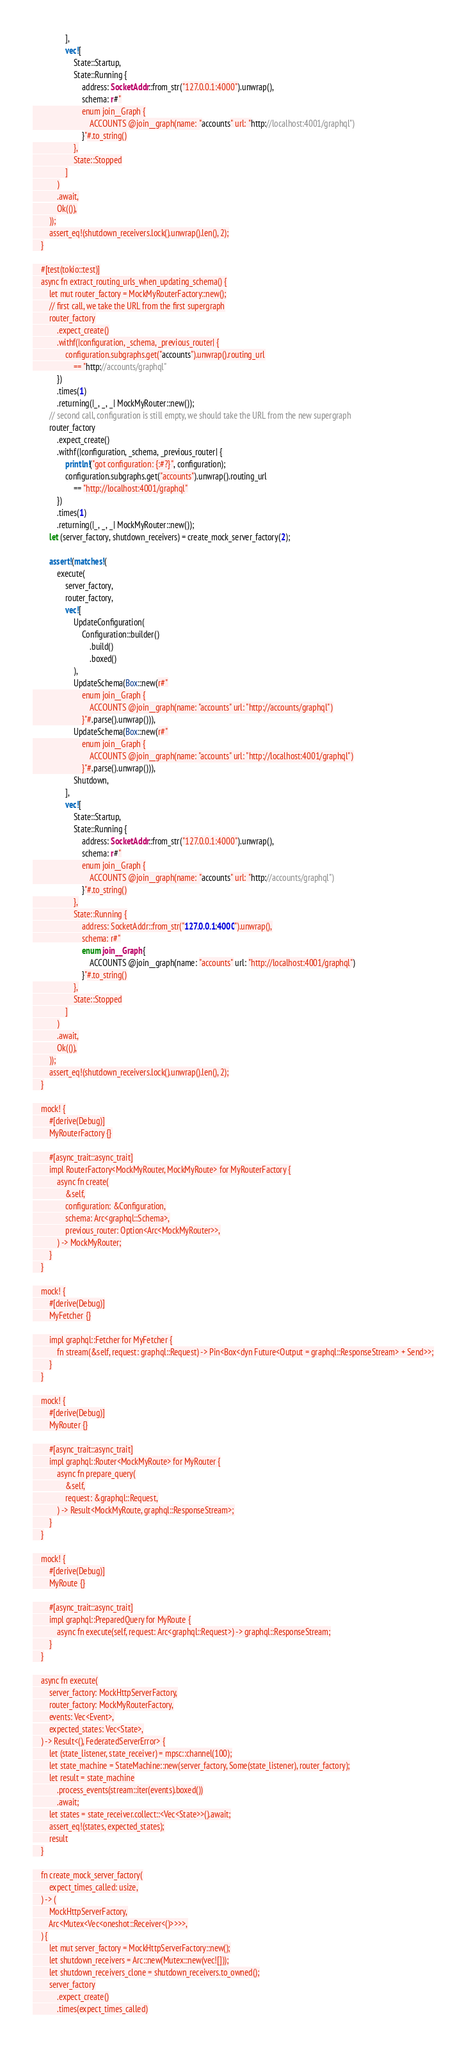Convert code to text. <code><loc_0><loc_0><loc_500><loc_500><_Rust_>                ],
                vec![
                    State::Startup,
                    State::Running {
                        address: SocketAddr::from_str("127.0.0.1:4000").unwrap(),
                        schema: r#"
                        enum join__Graph {
                            ACCOUNTS @join__graph(name: "accounts" url: "http://localhost:4001/graphql")
                        }"#.to_string()
                    },
                    State::Stopped
                ]
            )
            .await,
            Ok(()),
        ));
        assert_eq!(shutdown_receivers.lock().unwrap().len(), 2);
    }

    #[test(tokio::test)]
    async fn extract_routing_urls_when_updating_schema() {
        let mut router_factory = MockMyRouterFactory::new();
        // first call, we take the URL from the first supergraph
        router_factory
            .expect_create()
            .withf(|configuration, _schema, _previous_router| {
                configuration.subgraphs.get("accounts").unwrap().routing_url
                    == "http://accounts/graphql"
            })
            .times(1)
            .returning(|_, _, _| MockMyRouter::new());
        // second call, configuration is still empty, we should take the URL from the new supergraph
        router_factory
            .expect_create()
            .withf(|configuration, _schema, _previous_router| {
                println!("got configuration: {:#?}", configuration);
                configuration.subgraphs.get("accounts").unwrap().routing_url
                    == "http://localhost:4001/graphql"
            })
            .times(1)
            .returning(|_, _, _| MockMyRouter::new());
        let (server_factory, shutdown_receivers) = create_mock_server_factory(2);

        assert!(matches!(
            execute(
                server_factory,
                router_factory,
                vec![
                    UpdateConfiguration(
                        Configuration::builder()
                            .build()
                            .boxed()
                    ),
                    UpdateSchema(Box::new(r#"
                        enum join__Graph {
                            ACCOUNTS @join__graph(name: "accounts" url: "http://accounts/graphql")
                        }"#.parse().unwrap())),
                    UpdateSchema(Box::new(r#"
                        enum join__Graph {
                            ACCOUNTS @join__graph(name: "accounts" url: "http://localhost:4001/graphql")
                        }"#.parse().unwrap())),
                    Shutdown,
                ],
                vec![
                    State::Startup,
                    State::Running {
                        address: SocketAddr::from_str("127.0.0.1:4000").unwrap(),
                        schema: r#"
                        enum join__Graph {
                            ACCOUNTS @join__graph(name: "accounts" url: "http://accounts/graphql")
                        }"#.to_string()
                    },
                    State::Running {
                        address: SocketAddr::from_str("127.0.0.1:4000").unwrap(),
                        schema: r#"
                        enum join__Graph {
                            ACCOUNTS @join__graph(name: "accounts" url: "http://localhost:4001/graphql")
                        }"#.to_string()
                    },
                    State::Stopped
                ]
            )
            .await,
            Ok(()),
        ));
        assert_eq!(shutdown_receivers.lock().unwrap().len(), 2);
    }

    mock! {
        #[derive(Debug)]
        MyRouterFactory {}

        #[async_trait::async_trait]
        impl RouterFactory<MockMyRouter, MockMyRoute> for MyRouterFactory {
            async fn create(
                &self,
                configuration: &Configuration,
                schema: Arc<graphql::Schema>,
                previous_router: Option<Arc<MockMyRouter>>,
            ) -> MockMyRouter;
        }
    }

    mock! {
        #[derive(Debug)]
        MyFetcher {}

        impl graphql::Fetcher for MyFetcher {
            fn stream(&self, request: graphql::Request) -> Pin<Box<dyn Future<Output = graphql::ResponseStream> + Send>>;
        }
    }

    mock! {
        #[derive(Debug)]
        MyRouter {}

        #[async_trait::async_trait]
        impl graphql::Router<MockMyRoute> for MyRouter {
            async fn prepare_query(
                &self,
                request: &graphql::Request,
            ) -> Result<MockMyRoute, graphql::ResponseStream>;
        }
    }

    mock! {
        #[derive(Debug)]
        MyRoute {}

        #[async_trait::async_trait]
        impl graphql::PreparedQuery for MyRoute {
            async fn execute(self, request: Arc<graphql::Request>) -> graphql::ResponseStream;
        }
    }

    async fn execute(
        server_factory: MockHttpServerFactory,
        router_factory: MockMyRouterFactory,
        events: Vec<Event>,
        expected_states: Vec<State>,
    ) -> Result<(), FederatedServerError> {
        let (state_listener, state_receiver) = mpsc::channel(100);
        let state_machine = StateMachine::new(server_factory, Some(state_listener), router_factory);
        let result = state_machine
            .process_events(stream::iter(events).boxed())
            .await;
        let states = state_receiver.collect::<Vec<State>>().await;
        assert_eq!(states, expected_states);
        result
    }

    fn create_mock_server_factory(
        expect_times_called: usize,
    ) -> (
        MockHttpServerFactory,
        Arc<Mutex<Vec<oneshot::Receiver<()>>>>,
    ) {
        let mut server_factory = MockHttpServerFactory::new();
        let shutdown_receivers = Arc::new(Mutex::new(vec![]));
        let shutdown_receivers_clone = shutdown_receivers.to_owned();
        server_factory
            .expect_create()
            .times(expect_times_called)</code> 